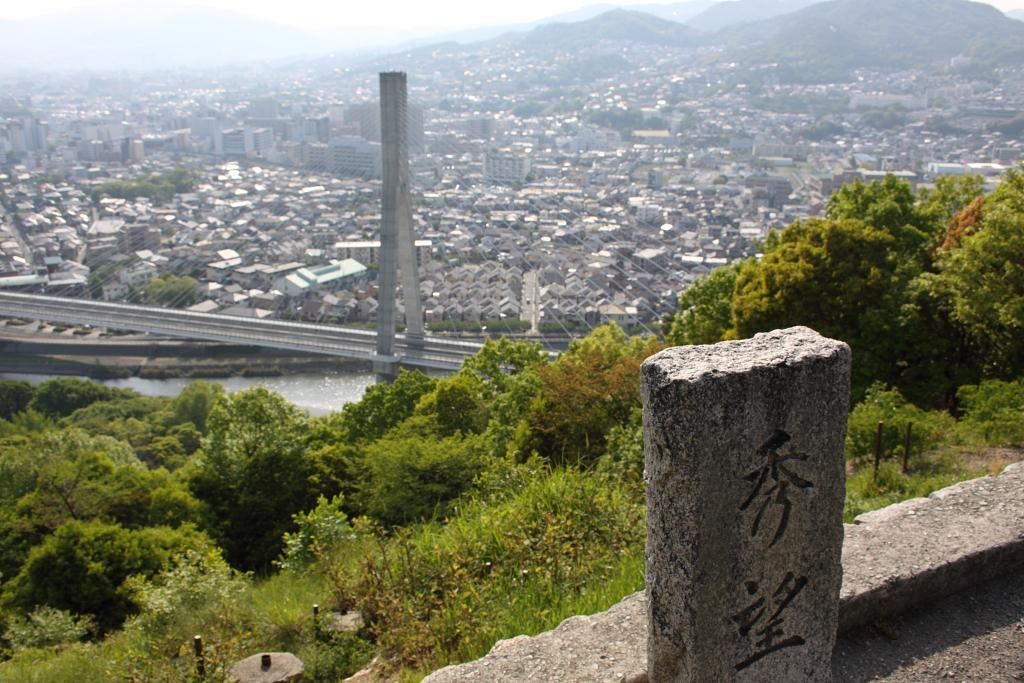What type of structures can be seen in the image? There are buildings in the image. What other natural elements are present in the image? There are trees and hills in the image. How would you describe the sky in the image? The sky is cloudy in the image. Can you identify any specific objects in the image? There is a stone visible in the image. What type of noise can be heard coming from the stone in the image? There is no noise coming from the stone in the image, as it is a stationary object. How does the pump function in the image? There is no pump present in the image. 